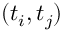<formula> <loc_0><loc_0><loc_500><loc_500>( t _ { i } , t _ { j } )</formula> 